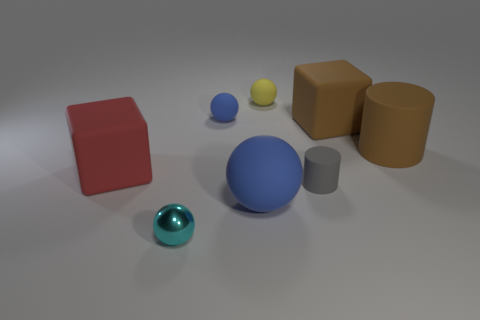There is a small blue matte thing; what shape is it?
Your answer should be very brief. Sphere. There is a cyan metallic object; how many big things are right of it?
Your answer should be very brief. 3. What number of large cyan cylinders are the same material as the red block?
Offer a very short reply. 0. Is the material of the big cube right of the yellow rubber thing the same as the yellow sphere?
Offer a terse response. Yes. Are there any big red objects?
Your answer should be compact. Yes. There is a object that is in front of the big red thing and behind the big rubber ball; what size is it?
Your answer should be compact. Small. Is the number of big matte cylinders to the right of the tiny yellow matte ball greater than the number of small yellow matte things to the right of the small gray thing?
Offer a very short reply. Yes. What is the size of the block that is the same color as the large cylinder?
Ensure brevity in your answer.  Large. The large sphere has what color?
Give a very brief answer. Blue. There is a tiny sphere that is behind the big blue matte object and in front of the tiny yellow thing; what is its color?
Offer a terse response. Blue. 